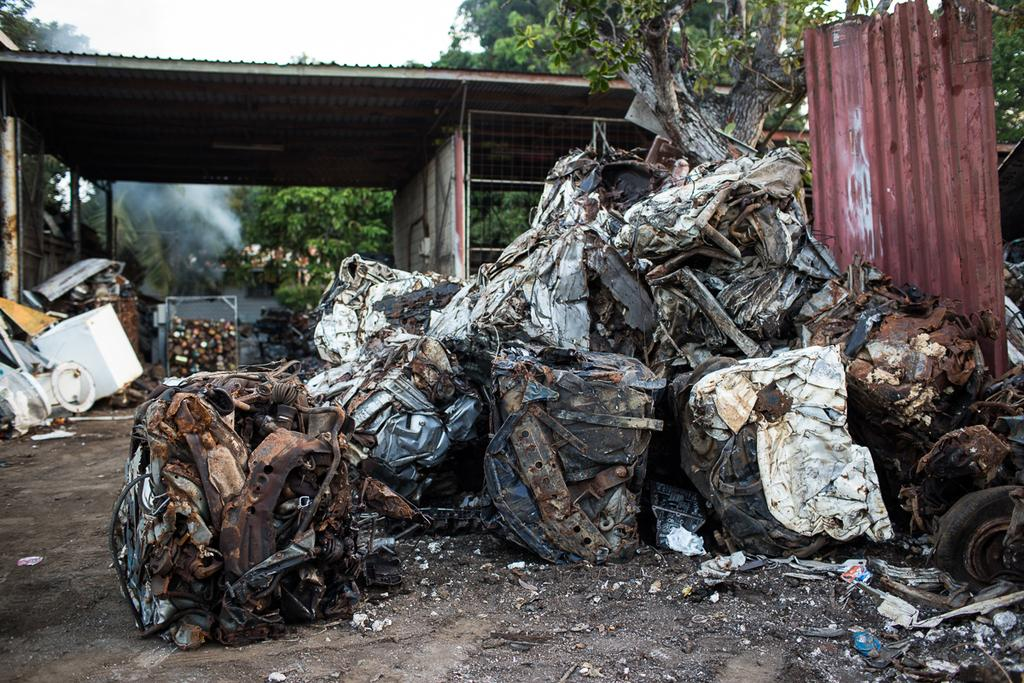What is located near the iron sheet in the image? There is scrap near the iron sheet in the image. What type of structure can be seen in the image? There is a shed in the image. What is visible in the background of the image? The sky is visible in the image, and clouds are present in the sky. What type of natural environment is depicted in the image? There are many trees in the image, indicating a forest or wooded area. Can you tell me how many lakes are visible in the image? There are no lakes visible in the image; it features a shed, trees, and an iron sheet with scrap near it. What type of collar is being worn by the trees in the image? There are no collars present in the image; the trees are depicted in a natural setting without any human-made accessories. 